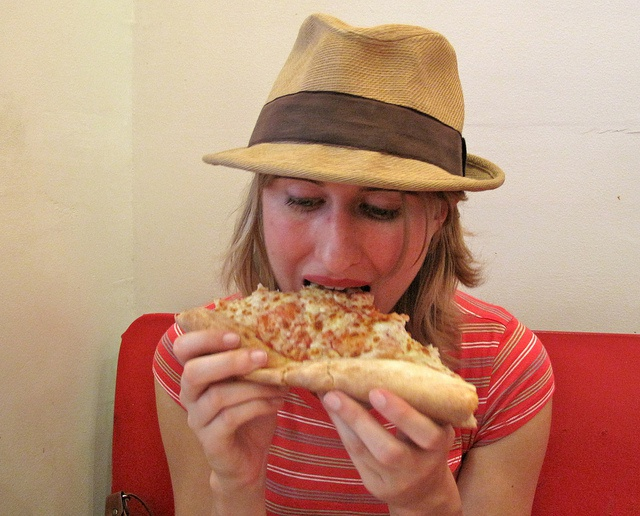Describe the objects in this image and their specific colors. I can see people in tan and brown tones and pizza in tan, brown, and salmon tones in this image. 